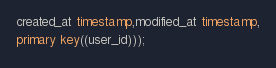<code> <loc_0><loc_0><loc_500><loc_500><_SQL_>created_at timestamp,modified_at timestamp,
primary key((user_id)));</code> 